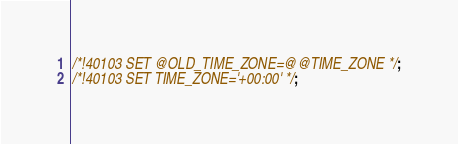<code> <loc_0><loc_0><loc_500><loc_500><_SQL_>/*!40103 SET @OLD_TIME_ZONE=@@TIME_ZONE */;
/*!40103 SET TIME_ZONE='+00:00' */;</code> 